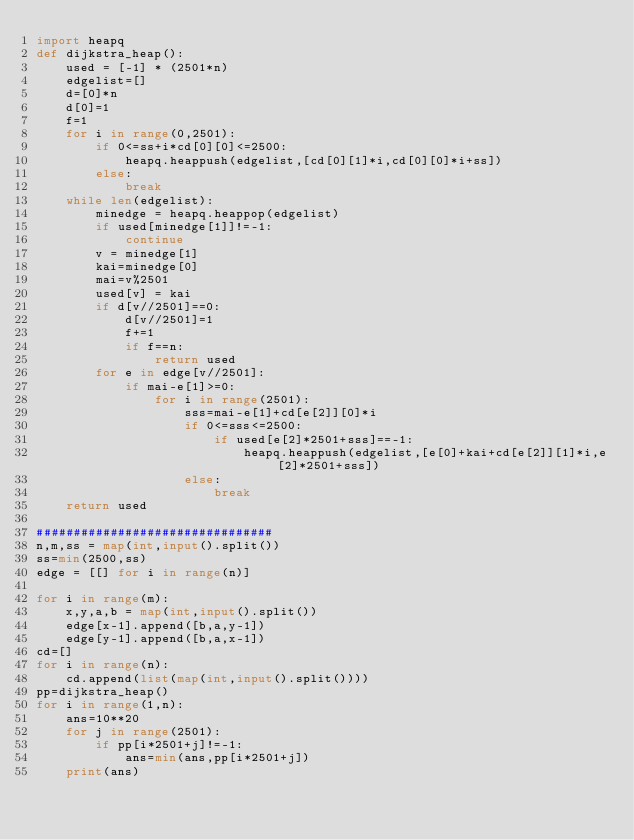Convert code to text. <code><loc_0><loc_0><loc_500><loc_500><_Python_>import heapq
def dijkstra_heap():
    used = [-1] * (2501*n)
    edgelist=[]
    d=[0]*n
    d[0]=1
    f=1
    for i in range(0,2501):
        if 0<=ss+i*cd[0][0]<=2500:
            heapq.heappush(edgelist,[cd[0][1]*i,cd[0][0]*i+ss])
        else:
            break
    while len(edgelist):
        minedge = heapq.heappop(edgelist)
        if used[minedge[1]]!=-1:
            continue
        v = minedge[1]
        kai=minedge[0]
        mai=v%2501
        used[v] = kai
        if d[v//2501]==0:
            d[v//2501]=1
            f+=1
            if f==n:
                return used
        for e in edge[v//2501]:
            if mai-e[1]>=0:
                for i in range(2501):
                    sss=mai-e[1]+cd[e[2]][0]*i
                    if 0<=sss<=2500:
                        if used[e[2]*2501+sss]==-1:
                            heapq.heappush(edgelist,[e[0]+kai+cd[e[2]][1]*i,e[2]*2501+sss])  
                    else:
                        break
    return used

################################
n,m,ss = map(int,input().split())
ss=min(2500,ss)
edge = [[] for i in range(n)]

for i in range(m):
    x,y,a,b = map(int,input().split())
    edge[x-1].append([b,a,y-1])
    edge[y-1].append([b,a,x-1])
cd=[]
for i in range(n):
    cd.append(list(map(int,input().split())))
pp=dijkstra_heap()
for i in range(1,n):
    ans=10**20
    for j in range(2501):
        if pp[i*2501+j]!=-1:
            ans=min(ans,pp[i*2501+j])
    print(ans)</code> 